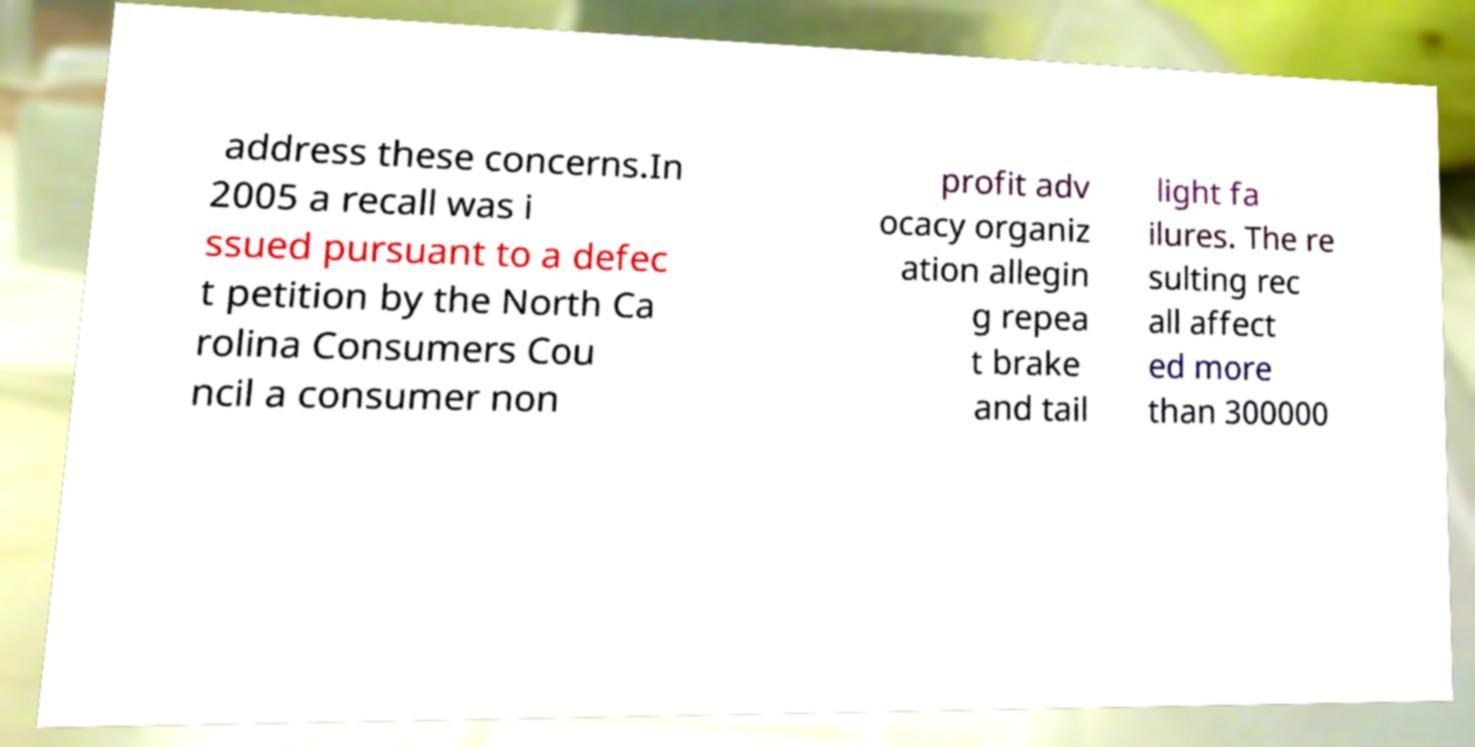Can you read and provide the text displayed in the image?This photo seems to have some interesting text. Can you extract and type it out for me? address these concerns.In 2005 a recall was i ssued pursuant to a defec t petition by the North Ca rolina Consumers Cou ncil a consumer non profit adv ocacy organiz ation allegin g repea t brake and tail light fa ilures. The re sulting rec all affect ed more than 300000 